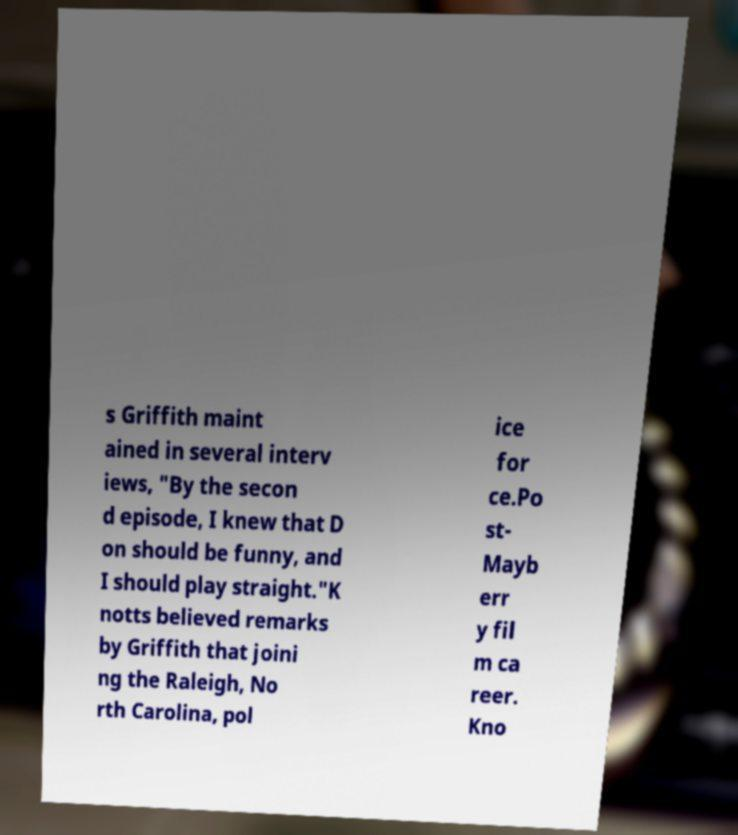For documentation purposes, I need the text within this image transcribed. Could you provide that? s Griffith maint ained in several interv iews, "By the secon d episode, I knew that D on should be funny, and I should play straight."K notts believed remarks by Griffith that joini ng the Raleigh, No rth Carolina, pol ice for ce.Po st- Mayb err y fil m ca reer. Kno 